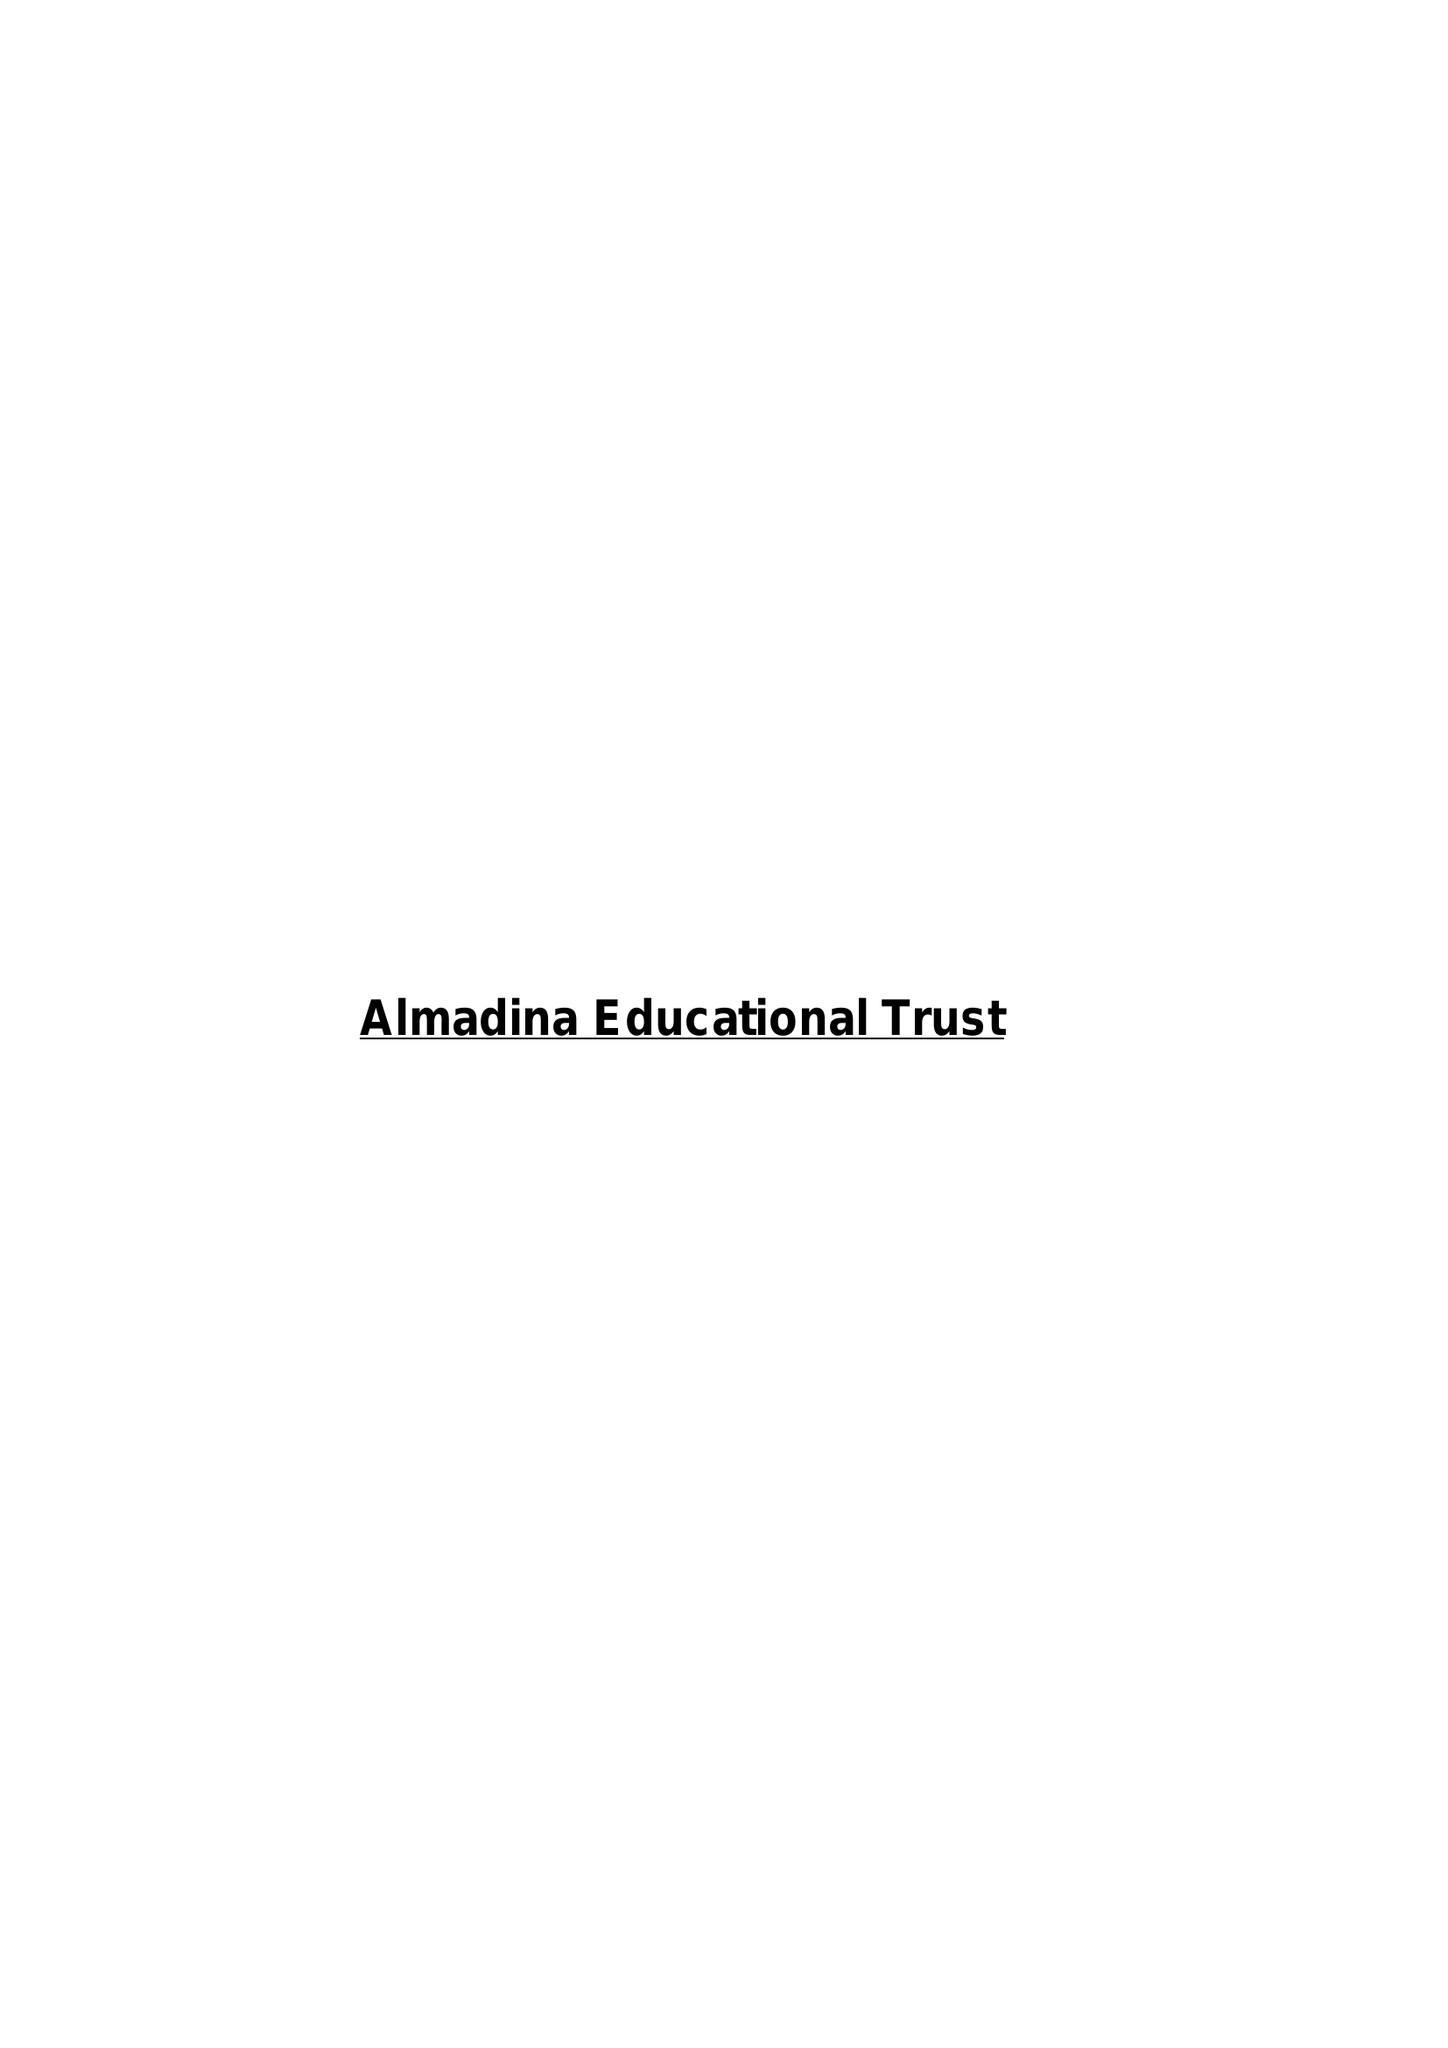What is the value for the address__post_town?
Answer the question using a single word or phrase. LITTLEBOROUGH 